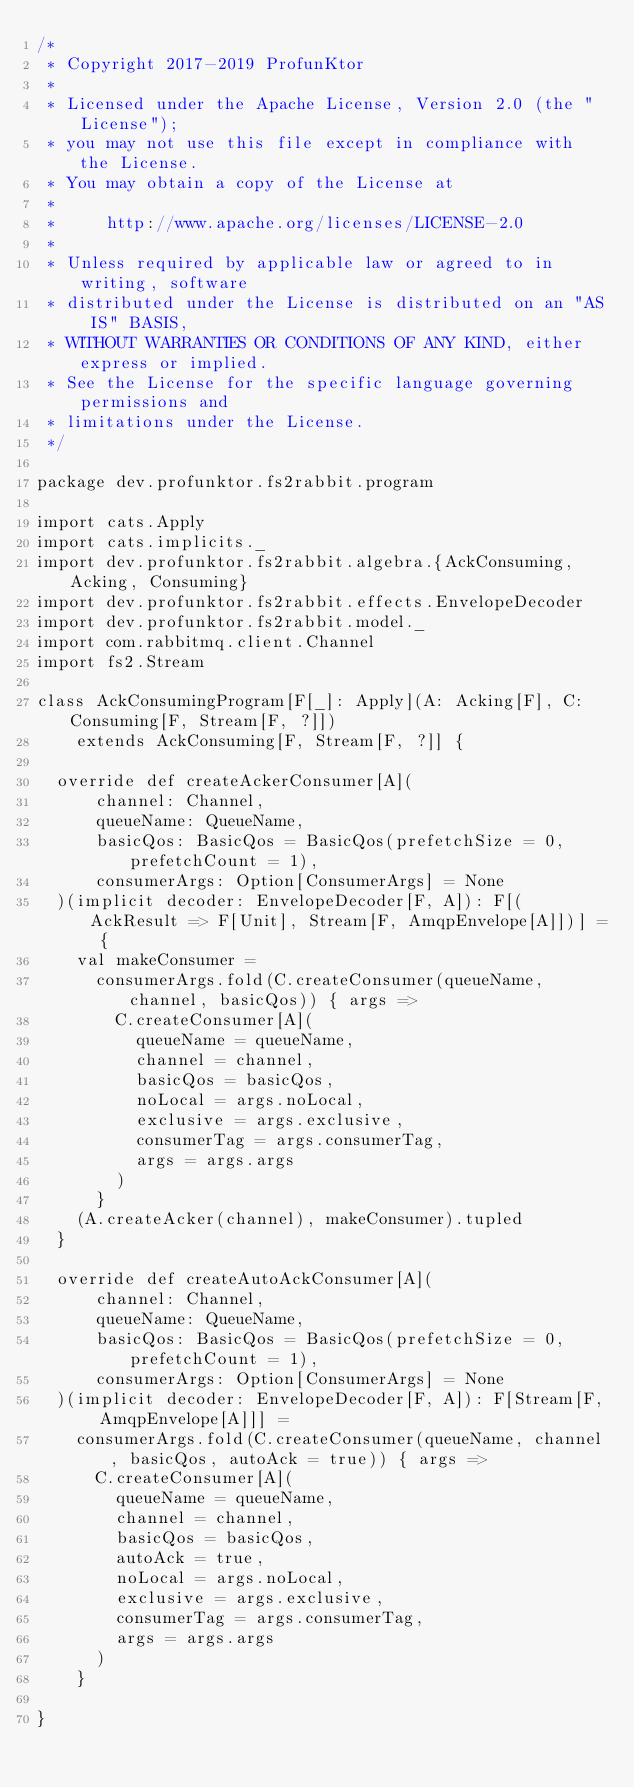<code> <loc_0><loc_0><loc_500><loc_500><_Scala_>/*
 * Copyright 2017-2019 ProfunKtor
 *
 * Licensed under the Apache License, Version 2.0 (the "License");
 * you may not use this file except in compliance with the License.
 * You may obtain a copy of the License at
 *
 *     http://www.apache.org/licenses/LICENSE-2.0
 *
 * Unless required by applicable law or agreed to in writing, software
 * distributed under the License is distributed on an "AS IS" BASIS,
 * WITHOUT WARRANTIES OR CONDITIONS OF ANY KIND, either express or implied.
 * See the License for the specific language governing permissions and
 * limitations under the License.
 */

package dev.profunktor.fs2rabbit.program

import cats.Apply
import cats.implicits._
import dev.profunktor.fs2rabbit.algebra.{AckConsuming, Acking, Consuming}
import dev.profunktor.fs2rabbit.effects.EnvelopeDecoder
import dev.profunktor.fs2rabbit.model._
import com.rabbitmq.client.Channel
import fs2.Stream

class AckConsumingProgram[F[_]: Apply](A: Acking[F], C: Consuming[F, Stream[F, ?]])
    extends AckConsuming[F, Stream[F, ?]] {

  override def createAckerConsumer[A](
      channel: Channel,
      queueName: QueueName,
      basicQos: BasicQos = BasicQos(prefetchSize = 0, prefetchCount = 1),
      consumerArgs: Option[ConsumerArgs] = None
  )(implicit decoder: EnvelopeDecoder[F, A]): F[(AckResult => F[Unit], Stream[F, AmqpEnvelope[A]])] = {
    val makeConsumer =
      consumerArgs.fold(C.createConsumer(queueName, channel, basicQos)) { args =>
        C.createConsumer[A](
          queueName = queueName,
          channel = channel,
          basicQos = basicQos,
          noLocal = args.noLocal,
          exclusive = args.exclusive,
          consumerTag = args.consumerTag,
          args = args.args
        )
      }
    (A.createAcker(channel), makeConsumer).tupled
  }

  override def createAutoAckConsumer[A](
      channel: Channel,
      queueName: QueueName,
      basicQos: BasicQos = BasicQos(prefetchSize = 0, prefetchCount = 1),
      consumerArgs: Option[ConsumerArgs] = None
  )(implicit decoder: EnvelopeDecoder[F, A]): F[Stream[F, AmqpEnvelope[A]]] =
    consumerArgs.fold(C.createConsumer(queueName, channel, basicQos, autoAck = true)) { args =>
      C.createConsumer[A](
        queueName = queueName,
        channel = channel,
        basicQos = basicQos,
        autoAck = true,
        noLocal = args.noLocal,
        exclusive = args.exclusive,
        consumerTag = args.consumerTag,
        args = args.args
      )
    }

}
</code> 